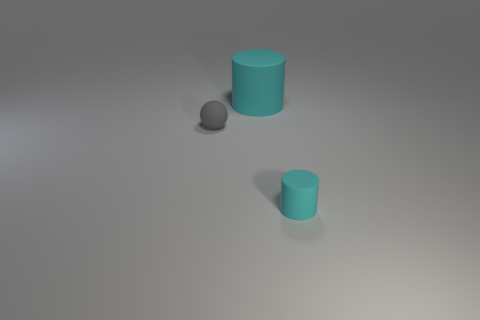Is the large matte cylinder the same color as the tiny cylinder?
Your answer should be compact. Yes. What is the size of the thing that is the same color as the big rubber cylinder?
Your answer should be very brief. Small. There is a tiny matte thing left of the rubber cylinder that is in front of the cyan cylinder behind the small cylinder; what is its color?
Give a very brief answer. Gray. There is a object in front of the tiny gray rubber thing; is it the same shape as the large matte thing?
Offer a terse response. Yes. How many red blocks are there?
Offer a terse response. 0. How many matte objects are the same size as the matte sphere?
Provide a succinct answer. 1. There is a small matte cylinder; does it have the same color as the cylinder behind the small cyan thing?
Give a very brief answer. Yes. How big is the thing that is both in front of the big rubber cylinder and on the left side of the tiny cyan matte cylinder?
Offer a terse response. Small. There is a small cyan thing that is the same material as the big thing; what shape is it?
Your answer should be compact. Cylinder. There is a cyan rubber object that is in front of the big cyan matte cylinder; is there a cyan object behind it?
Offer a very short reply. Yes. 